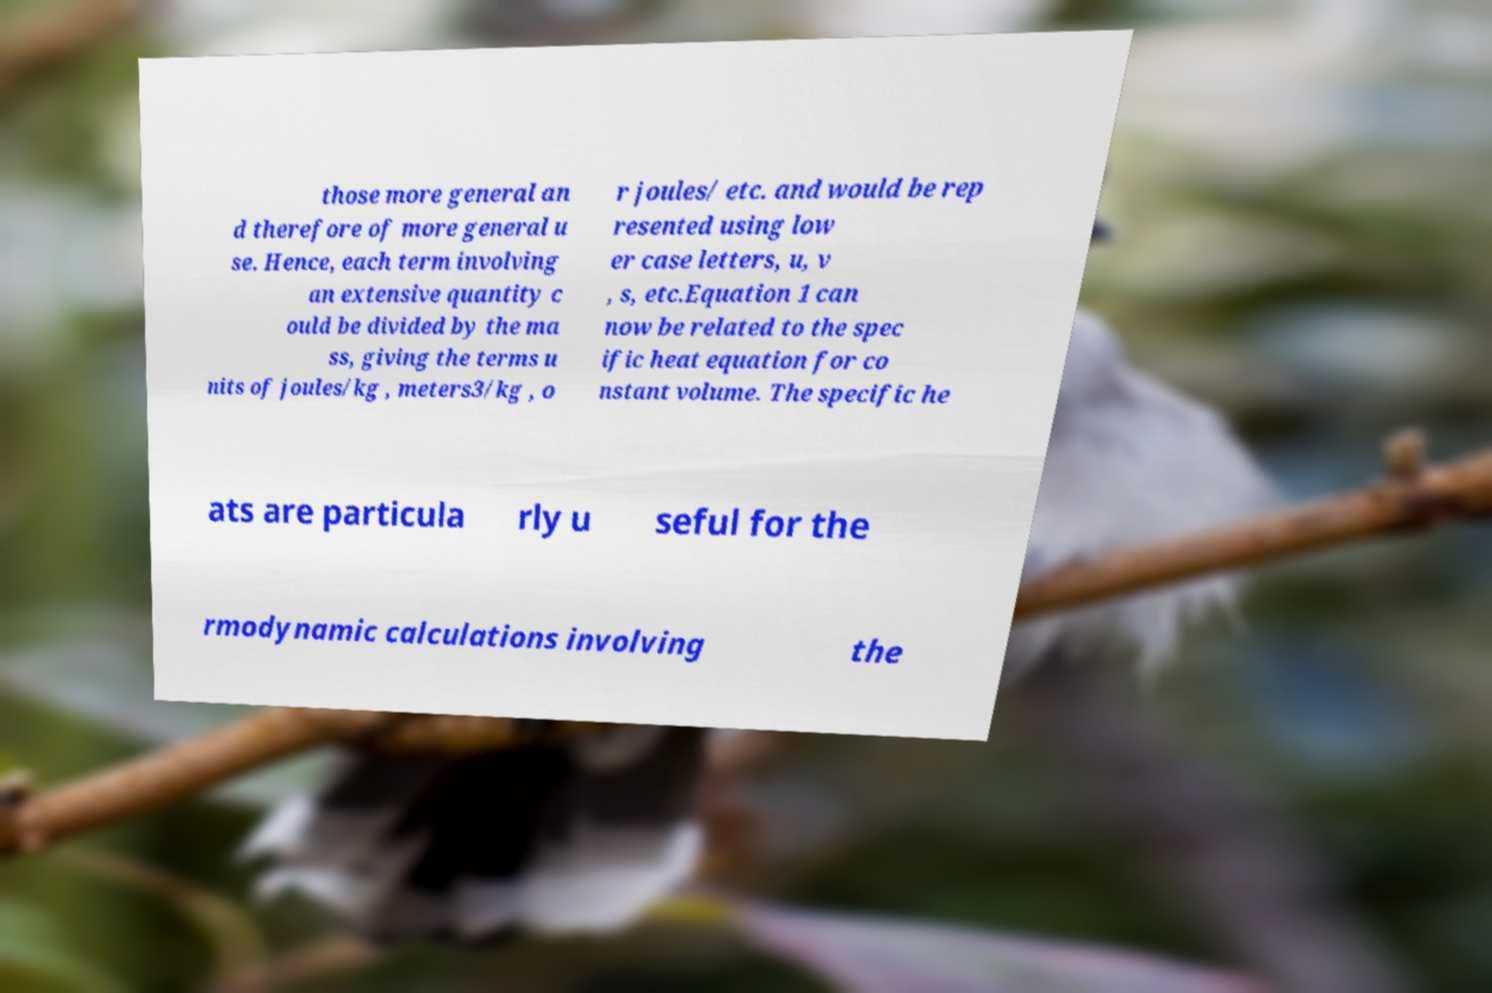Could you extract and type out the text from this image? those more general an d therefore of more general u se. Hence, each term involving an extensive quantity c ould be divided by the ma ss, giving the terms u nits of joules/kg , meters3/kg , o r joules/ etc. and would be rep resented using low er case letters, u, v , s, etc.Equation 1 can now be related to the spec ific heat equation for co nstant volume. The specific he ats are particula rly u seful for the rmodynamic calculations involving the 